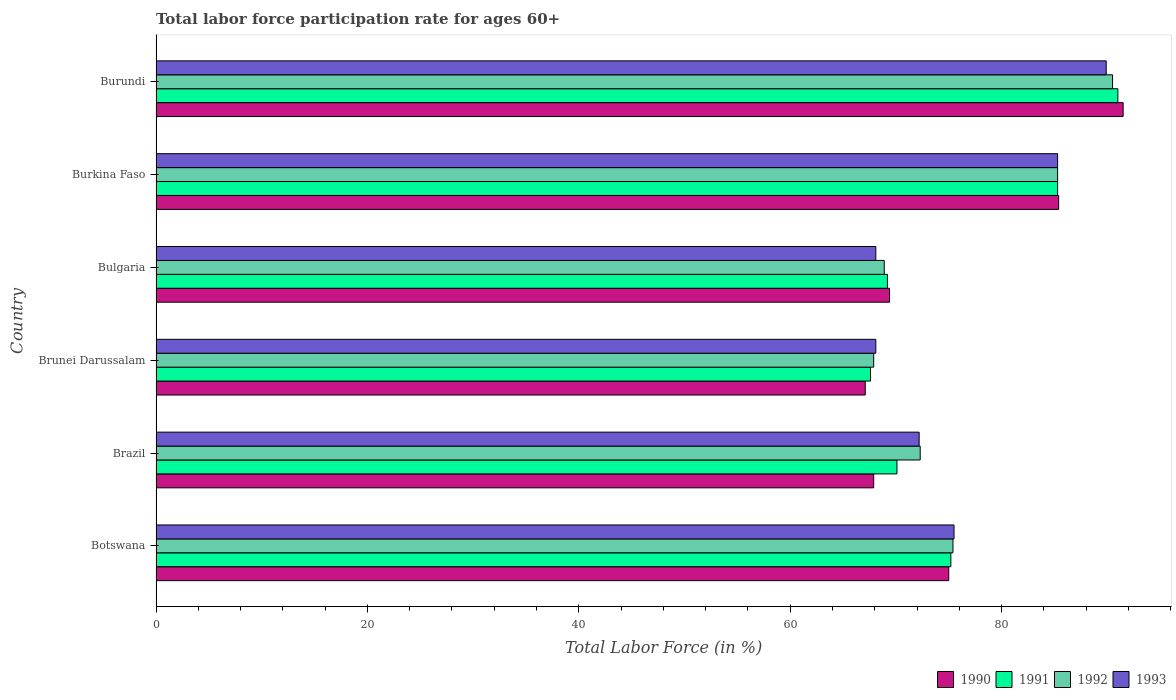How many groups of bars are there?
Your response must be concise. 6. How many bars are there on the 6th tick from the top?
Offer a terse response. 4. How many bars are there on the 4th tick from the bottom?
Give a very brief answer. 4. What is the label of the 3rd group of bars from the top?
Offer a very short reply. Bulgaria. In how many cases, is the number of bars for a given country not equal to the number of legend labels?
Your answer should be compact. 0. What is the labor force participation rate in 1992 in Burkina Faso?
Provide a short and direct response. 85.3. Across all countries, what is the maximum labor force participation rate in 1992?
Ensure brevity in your answer.  90.5. Across all countries, what is the minimum labor force participation rate in 1990?
Give a very brief answer. 67.1. In which country was the labor force participation rate in 1990 maximum?
Your answer should be very brief. Burundi. In which country was the labor force participation rate in 1991 minimum?
Keep it short and to the point. Brunei Darussalam. What is the total labor force participation rate in 1991 in the graph?
Your answer should be compact. 458.4. What is the difference between the labor force participation rate in 1992 in Botswana and that in Brunei Darussalam?
Give a very brief answer. 7.5. What is the difference between the labor force participation rate in 1992 in Burundi and the labor force participation rate in 1991 in Brunei Darussalam?
Provide a succinct answer. 22.9. What is the average labor force participation rate in 1993 per country?
Your answer should be very brief. 76.52. What is the difference between the labor force participation rate in 1993 and labor force participation rate in 1990 in Botswana?
Your answer should be compact. 0.5. In how many countries, is the labor force participation rate in 1992 greater than 4 %?
Provide a succinct answer. 6. What is the ratio of the labor force participation rate in 1992 in Botswana to that in Burkina Faso?
Make the answer very short. 0.88. Is the difference between the labor force participation rate in 1993 in Burkina Faso and Burundi greater than the difference between the labor force participation rate in 1990 in Burkina Faso and Burundi?
Keep it short and to the point. Yes. What is the difference between the highest and the second highest labor force participation rate in 1990?
Your answer should be very brief. 6.1. What is the difference between the highest and the lowest labor force participation rate in 1990?
Your response must be concise. 24.4. Is it the case that in every country, the sum of the labor force participation rate in 1992 and labor force participation rate in 1991 is greater than the sum of labor force participation rate in 1990 and labor force participation rate in 1993?
Give a very brief answer. No. What does the 1st bar from the bottom in Brunei Darussalam represents?
Offer a terse response. 1990. How many bars are there?
Provide a succinct answer. 24. Are all the bars in the graph horizontal?
Provide a short and direct response. Yes. Are the values on the major ticks of X-axis written in scientific E-notation?
Keep it short and to the point. No. Does the graph contain any zero values?
Make the answer very short. No. Does the graph contain grids?
Your answer should be very brief. No. How many legend labels are there?
Offer a very short reply. 4. What is the title of the graph?
Ensure brevity in your answer.  Total labor force participation rate for ages 60+. Does "1983" appear as one of the legend labels in the graph?
Make the answer very short. No. What is the label or title of the X-axis?
Make the answer very short. Total Labor Force (in %). What is the label or title of the Y-axis?
Offer a terse response. Country. What is the Total Labor Force (in %) of 1991 in Botswana?
Give a very brief answer. 75.2. What is the Total Labor Force (in %) in 1992 in Botswana?
Your response must be concise. 75.4. What is the Total Labor Force (in %) of 1993 in Botswana?
Give a very brief answer. 75.5. What is the Total Labor Force (in %) in 1990 in Brazil?
Your answer should be very brief. 67.9. What is the Total Labor Force (in %) in 1991 in Brazil?
Make the answer very short. 70.1. What is the Total Labor Force (in %) of 1992 in Brazil?
Offer a terse response. 72.3. What is the Total Labor Force (in %) of 1993 in Brazil?
Give a very brief answer. 72.2. What is the Total Labor Force (in %) of 1990 in Brunei Darussalam?
Your response must be concise. 67.1. What is the Total Labor Force (in %) of 1991 in Brunei Darussalam?
Keep it short and to the point. 67.6. What is the Total Labor Force (in %) of 1992 in Brunei Darussalam?
Give a very brief answer. 67.9. What is the Total Labor Force (in %) in 1993 in Brunei Darussalam?
Offer a very short reply. 68.1. What is the Total Labor Force (in %) of 1990 in Bulgaria?
Offer a very short reply. 69.4. What is the Total Labor Force (in %) in 1991 in Bulgaria?
Give a very brief answer. 69.2. What is the Total Labor Force (in %) in 1992 in Bulgaria?
Offer a terse response. 68.9. What is the Total Labor Force (in %) in 1993 in Bulgaria?
Provide a short and direct response. 68.1. What is the Total Labor Force (in %) of 1990 in Burkina Faso?
Provide a succinct answer. 85.4. What is the Total Labor Force (in %) of 1991 in Burkina Faso?
Give a very brief answer. 85.3. What is the Total Labor Force (in %) of 1992 in Burkina Faso?
Provide a succinct answer. 85.3. What is the Total Labor Force (in %) in 1993 in Burkina Faso?
Your response must be concise. 85.3. What is the Total Labor Force (in %) in 1990 in Burundi?
Make the answer very short. 91.5. What is the Total Labor Force (in %) of 1991 in Burundi?
Offer a terse response. 91. What is the Total Labor Force (in %) of 1992 in Burundi?
Give a very brief answer. 90.5. What is the Total Labor Force (in %) of 1993 in Burundi?
Give a very brief answer. 89.9. Across all countries, what is the maximum Total Labor Force (in %) in 1990?
Give a very brief answer. 91.5. Across all countries, what is the maximum Total Labor Force (in %) of 1991?
Offer a terse response. 91. Across all countries, what is the maximum Total Labor Force (in %) in 1992?
Provide a short and direct response. 90.5. Across all countries, what is the maximum Total Labor Force (in %) of 1993?
Offer a very short reply. 89.9. Across all countries, what is the minimum Total Labor Force (in %) of 1990?
Provide a succinct answer. 67.1. Across all countries, what is the minimum Total Labor Force (in %) of 1991?
Your response must be concise. 67.6. Across all countries, what is the minimum Total Labor Force (in %) in 1992?
Offer a terse response. 67.9. Across all countries, what is the minimum Total Labor Force (in %) in 1993?
Give a very brief answer. 68.1. What is the total Total Labor Force (in %) of 1990 in the graph?
Offer a terse response. 456.3. What is the total Total Labor Force (in %) in 1991 in the graph?
Give a very brief answer. 458.4. What is the total Total Labor Force (in %) in 1992 in the graph?
Ensure brevity in your answer.  460.3. What is the total Total Labor Force (in %) of 1993 in the graph?
Your answer should be compact. 459.1. What is the difference between the Total Labor Force (in %) of 1990 in Botswana and that in Brazil?
Your response must be concise. 7.1. What is the difference between the Total Labor Force (in %) in 1990 in Botswana and that in Brunei Darussalam?
Ensure brevity in your answer.  7.9. What is the difference between the Total Labor Force (in %) in 1993 in Botswana and that in Brunei Darussalam?
Offer a very short reply. 7.4. What is the difference between the Total Labor Force (in %) in 1990 in Botswana and that in Bulgaria?
Keep it short and to the point. 5.6. What is the difference between the Total Labor Force (in %) of 1991 in Botswana and that in Bulgaria?
Your answer should be very brief. 6. What is the difference between the Total Labor Force (in %) in 1993 in Botswana and that in Bulgaria?
Your response must be concise. 7.4. What is the difference between the Total Labor Force (in %) of 1993 in Botswana and that in Burkina Faso?
Your answer should be very brief. -9.8. What is the difference between the Total Labor Force (in %) of 1990 in Botswana and that in Burundi?
Keep it short and to the point. -16.5. What is the difference between the Total Labor Force (in %) of 1991 in Botswana and that in Burundi?
Provide a succinct answer. -15.8. What is the difference between the Total Labor Force (in %) in 1992 in Botswana and that in Burundi?
Keep it short and to the point. -15.1. What is the difference between the Total Labor Force (in %) of 1993 in Botswana and that in Burundi?
Make the answer very short. -14.4. What is the difference between the Total Labor Force (in %) of 1990 in Brazil and that in Brunei Darussalam?
Keep it short and to the point. 0.8. What is the difference between the Total Labor Force (in %) in 1990 in Brazil and that in Bulgaria?
Provide a succinct answer. -1.5. What is the difference between the Total Labor Force (in %) in 1991 in Brazil and that in Bulgaria?
Offer a terse response. 0.9. What is the difference between the Total Labor Force (in %) in 1992 in Brazil and that in Bulgaria?
Make the answer very short. 3.4. What is the difference between the Total Labor Force (in %) in 1993 in Brazil and that in Bulgaria?
Your response must be concise. 4.1. What is the difference between the Total Labor Force (in %) of 1990 in Brazil and that in Burkina Faso?
Offer a terse response. -17.5. What is the difference between the Total Labor Force (in %) in 1991 in Brazil and that in Burkina Faso?
Give a very brief answer. -15.2. What is the difference between the Total Labor Force (in %) in 1992 in Brazil and that in Burkina Faso?
Keep it short and to the point. -13. What is the difference between the Total Labor Force (in %) of 1993 in Brazil and that in Burkina Faso?
Offer a terse response. -13.1. What is the difference between the Total Labor Force (in %) in 1990 in Brazil and that in Burundi?
Offer a very short reply. -23.6. What is the difference between the Total Labor Force (in %) of 1991 in Brazil and that in Burundi?
Offer a terse response. -20.9. What is the difference between the Total Labor Force (in %) of 1992 in Brazil and that in Burundi?
Your answer should be compact. -18.2. What is the difference between the Total Labor Force (in %) of 1993 in Brazil and that in Burundi?
Your response must be concise. -17.7. What is the difference between the Total Labor Force (in %) in 1990 in Brunei Darussalam and that in Bulgaria?
Provide a short and direct response. -2.3. What is the difference between the Total Labor Force (in %) in 1990 in Brunei Darussalam and that in Burkina Faso?
Offer a very short reply. -18.3. What is the difference between the Total Labor Force (in %) in 1991 in Brunei Darussalam and that in Burkina Faso?
Keep it short and to the point. -17.7. What is the difference between the Total Labor Force (in %) in 1992 in Brunei Darussalam and that in Burkina Faso?
Your answer should be very brief. -17.4. What is the difference between the Total Labor Force (in %) of 1993 in Brunei Darussalam and that in Burkina Faso?
Your answer should be very brief. -17.2. What is the difference between the Total Labor Force (in %) in 1990 in Brunei Darussalam and that in Burundi?
Make the answer very short. -24.4. What is the difference between the Total Labor Force (in %) of 1991 in Brunei Darussalam and that in Burundi?
Offer a very short reply. -23.4. What is the difference between the Total Labor Force (in %) of 1992 in Brunei Darussalam and that in Burundi?
Provide a succinct answer. -22.6. What is the difference between the Total Labor Force (in %) of 1993 in Brunei Darussalam and that in Burundi?
Offer a terse response. -21.8. What is the difference between the Total Labor Force (in %) of 1991 in Bulgaria and that in Burkina Faso?
Your answer should be very brief. -16.1. What is the difference between the Total Labor Force (in %) in 1992 in Bulgaria and that in Burkina Faso?
Ensure brevity in your answer.  -16.4. What is the difference between the Total Labor Force (in %) of 1993 in Bulgaria and that in Burkina Faso?
Provide a short and direct response. -17.2. What is the difference between the Total Labor Force (in %) in 1990 in Bulgaria and that in Burundi?
Ensure brevity in your answer.  -22.1. What is the difference between the Total Labor Force (in %) of 1991 in Bulgaria and that in Burundi?
Make the answer very short. -21.8. What is the difference between the Total Labor Force (in %) of 1992 in Bulgaria and that in Burundi?
Your answer should be compact. -21.6. What is the difference between the Total Labor Force (in %) in 1993 in Bulgaria and that in Burundi?
Ensure brevity in your answer.  -21.8. What is the difference between the Total Labor Force (in %) of 1990 in Burkina Faso and that in Burundi?
Your response must be concise. -6.1. What is the difference between the Total Labor Force (in %) in 1991 in Burkina Faso and that in Burundi?
Your response must be concise. -5.7. What is the difference between the Total Labor Force (in %) of 1992 in Burkina Faso and that in Burundi?
Your answer should be compact. -5.2. What is the difference between the Total Labor Force (in %) of 1990 in Botswana and the Total Labor Force (in %) of 1991 in Brazil?
Ensure brevity in your answer.  4.9. What is the difference between the Total Labor Force (in %) in 1990 in Botswana and the Total Labor Force (in %) in 1992 in Brazil?
Provide a succinct answer. 2.7. What is the difference between the Total Labor Force (in %) in 1990 in Botswana and the Total Labor Force (in %) in 1993 in Brazil?
Keep it short and to the point. 2.8. What is the difference between the Total Labor Force (in %) of 1991 in Botswana and the Total Labor Force (in %) of 1993 in Brazil?
Keep it short and to the point. 3. What is the difference between the Total Labor Force (in %) in 1990 in Botswana and the Total Labor Force (in %) in 1991 in Brunei Darussalam?
Give a very brief answer. 7.4. What is the difference between the Total Labor Force (in %) of 1990 in Botswana and the Total Labor Force (in %) of 1992 in Brunei Darussalam?
Provide a succinct answer. 7.1. What is the difference between the Total Labor Force (in %) in 1990 in Botswana and the Total Labor Force (in %) in 1993 in Brunei Darussalam?
Your response must be concise. 6.9. What is the difference between the Total Labor Force (in %) in 1990 in Botswana and the Total Labor Force (in %) in 1991 in Bulgaria?
Your answer should be very brief. 5.8. What is the difference between the Total Labor Force (in %) in 1990 in Botswana and the Total Labor Force (in %) in 1992 in Bulgaria?
Give a very brief answer. 6.1. What is the difference between the Total Labor Force (in %) of 1990 in Botswana and the Total Labor Force (in %) of 1993 in Bulgaria?
Keep it short and to the point. 6.9. What is the difference between the Total Labor Force (in %) in 1991 in Botswana and the Total Labor Force (in %) in 1992 in Bulgaria?
Provide a short and direct response. 6.3. What is the difference between the Total Labor Force (in %) of 1992 in Botswana and the Total Labor Force (in %) of 1993 in Bulgaria?
Your answer should be compact. 7.3. What is the difference between the Total Labor Force (in %) of 1990 in Botswana and the Total Labor Force (in %) of 1991 in Burkina Faso?
Offer a terse response. -10.3. What is the difference between the Total Labor Force (in %) of 1990 in Botswana and the Total Labor Force (in %) of 1992 in Burkina Faso?
Your answer should be compact. -10.3. What is the difference between the Total Labor Force (in %) in 1990 in Botswana and the Total Labor Force (in %) in 1991 in Burundi?
Provide a succinct answer. -16. What is the difference between the Total Labor Force (in %) in 1990 in Botswana and the Total Labor Force (in %) in 1992 in Burundi?
Provide a succinct answer. -15.5. What is the difference between the Total Labor Force (in %) of 1990 in Botswana and the Total Labor Force (in %) of 1993 in Burundi?
Offer a very short reply. -14.9. What is the difference between the Total Labor Force (in %) of 1991 in Botswana and the Total Labor Force (in %) of 1992 in Burundi?
Your answer should be very brief. -15.3. What is the difference between the Total Labor Force (in %) in 1991 in Botswana and the Total Labor Force (in %) in 1993 in Burundi?
Provide a succinct answer. -14.7. What is the difference between the Total Labor Force (in %) of 1992 in Botswana and the Total Labor Force (in %) of 1993 in Burundi?
Make the answer very short. -14.5. What is the difference between the Total Labor Force (in %) of 1990 in Brazil and the Total Labor Force (in %) of 1992 in Brunei Darussalam?
Your answer should be compact. 0. What is the difference between the Total Labor Force (in %) of 1990 in Brazil and the Total Labor Force (in %) of 1993 in Brunei Darussalam?
Give a very brief answer. -0.2. What is the difference between the Total Labor Force (in %) of 1992 in Brazil and the Total Labor Force (in %) of 1993 in Brunei Darussalam?
Your response must be concise. 4.2. What is the difference between the Total Labor Force (in %) of 1992 in Brazil and the Total Labor Force (in %) of 1993 in Bulgaria?
Give a very brief answer. 4.2. What is the difference between the Total Labor Force (in %) of 1990 in Brazil and the Total Labor Force (in %) of 1991 in Burkina Faso?
Give a very brief answer. -17.4. What is the difference between the Total Labor Force (in %) of 1990 in Brazil and the Total Labor Force (in %) of 1992 in Burkina Faso?
Your response must be concise. -17.4. What is the difference between the Total Labor Force (in %) of 1990 in Brazil and the Total Labor Force (in %) of 1993 in Burkina Faso?
Offer a very short reply. -17.4. What is the difference between the Total Labor Force (in %) of 1991 in Brazil and the Total Labor Force (in %) of 1992 in Burkina Faso?
Keep it short and to the point. -15.2. What is the difference between the Total Labor Force (in %) in 1991 in Brazil and the Total Labor Force (in %) in 1993 in Burkina Faso?
Give a very brief answer. -15.2. What is the difference between the Total Labor Force (in %) in 1990 in Brazil and the Total Labor Force (in %) in 1991 in Burundi?
Ensure brevity in your answer.  -23.1. What is the difference between the Total Labor Force (in %) in 1990 in Brazil and the Total Labor Force (in %) in 1992 in Burundi?
Your response must be concise. -22.6. What is the difference between the Total Labor Force (in %) in 1990 in Brazil and the Total Labor Force (in %) in 1993 in Burundi?
Your answer should be compact. -22. What is the difference between the Total Labor Force (in %) in 1991 in Brazil and the Total Labor Force (in %) in 1992 in Burundi?
Your answer should be compact. -20.4. What is the difference between the Total Labor Force (in %) of 1991 in Brazil and the Total Labor Force (in %) of 1993 in Burundi?
Keep it short and to the point. -19.8. What is the difference between the Total Labor Force (in %) of 1992 in Brazil and the Total Labor Force (in %) of 1993 in Burundi?
Give a very brief answer. -17.6. What is the difference between the Total Labor Force (in %) of 1990 in Brunei Darussalam and the Total Labor Force (in %) of 1991 in Bulgaria?
Your answer should be very brief. -2.1. What is the difference between the Total Labor Force (in %) in 1990 in Brunei Darussalam and the Total Labor Force (in %) in 1993 in Bulgaria?
Provide a short and direct response. -1. What is the difference between the Total Labor Force (in %) in 1991 in Brunei Darussalam and the Total Labor Force (in %) in 1993 in Bulgaria?
Your answer should be very brief. -0.5. What is the difference between the Total Labor Force (in %) in 1990 in Brunei Darussalam and the Total Labor Force (in %) in 1991 in Burkina Faso?
Make the answer very short. -18.2. What is the difference between the Total Labor Force (in %) in 1990 in Brunei Darussalam and the Total Labor Force (in %) in 1992 in Burkina Faso?
Keep it short and to the point. -18.2. What is the difference between the Total Labor Force (in %) in 1990 in Brunei Darussalam and the Total Labor Force (in %) in 1993 in Burkina Faso?
Offer a very short reply. -18.2. What is the difference between the Total Labor Force (in %) in 1991 in Brunei Darussalam and the Total Labor Force (in %) in 1992 in Burkina Faso?
Give a very brief answer. -17.7. What is the difference between the Total Labor Force (in %) of 1991 in Brunei Darussalam and the Total Labor Force (in %) of 1993 in Burkina Faso?
Give a very brief answer. -17.7. What is the difference between the Total Labor Force (in %) in 1992 in Brunei Darussalam and the Total Labor Force (in %) in 1993 in Burkina Faso?
Offer a very short reply. -17.4. What is the difference between the Total Labor Force (in %) in 1990 in Brunei Darussalam and the Total Labor Force (in %) in 1991 in Burundi?
Your answer should be very brief. -23.9. What is the difference between the Total Labor Force (in %) in 1990 in Brunei Darussalam and the Total Labor Force (in %) in 1992 in Burundi?
Give a very brief answer. -23.4. What is the difference between the Total Labor Force (in %) in 1990 in Brunei Darussalam and the Total Labor Force (in %) in 1993 in Burundi?
Your answer should be very brief. -22.8. What is the difference between the Total Labor Force (in %) in 1991 in Brunei Darussalam and the Total Labor Force (in %) in 1992 in Burundi?
Your answer should be very brief. -22.9. What is the difference between the Total Labor Force (in %) of 1991 in Brunei Darussalam and the Total Labor Force (in %) of 1993 in Burundi?
Your answer should be compact. -22.3. What is the difference between the Total Labor Force (in %) in 1990 in Bulgaria and the Total Labor Force (in %) in 1991 in Burkina Faso?
Keep it short and to the point. -15.9. What is the difference between the Total Labor Force (in %) of 1990 in Bulgaria and the Total Labor Force (in %) of 1992 in Burkina Faso?
Provide a succinct answer. -15.9. What is the difference between the Total Labor Force (in %) in 1990 in Bulgaria and the Total Labor Force (in %) in 1993 in Burkina Faso?
Your answer should be very brief. -15.9. What is the difference between the Total Labor Force (in %) in 1991 in Bulgaria and the Total Labor Force (in %) in 1992 in Burkina Faso?
Provide a succinct answer. -16.1. What is the difference between the Total Labor Force (in %) of 1991 in Bulgaria and the Total Labor Force (in %) of 1993 in Burkina Faso?
Make the answer very short. -16.1. What is the difference between the Total Labor Force (in %) in 1992 in Bulgaria and the Total Labor Force (in %) in 1993 in Burkina Faso?
Keep it short and to the point. -16.4. What is the difference between the Total Labor Force (in %) of 1990 in Bulgaria and the Total Labor Force (in %) of 1991 in Burundi?
Make the answer very short. -21.6. What is the difference between the Total Labor Force (in %) in 1990 in Bulgaria and the Total Labor Force (in %) in 1992 in Burundi?
Keep it short and to the point. -21.1. What is the difference between the Total Labor Force (in %) in 1990 in Bulgaria and the Total Labor Force (in %) in 1993 in Burundi?
Provide a short and direct response. -20.5. What is the difference between the Total Labor Force (in %) in 1991 in Bulgaria and the Total Labor Force (in %) in 1992 in Burundi?
Ensure brevity in your answer.  -21.3. What is the difference between the Total Labor Force (in %) in 1991 in Bulgaria and the Total Labor Force (in %) in 1993 in Burundi?
Your response must be concise. -20.7. What is the difference between the Total Labor Force (in %) in 1992 in Bulgaria and the Total Labor Force (in %) in 1993 in Burundi?
Your answer should be compact. -21. What is the difference between the Total Labor Force (in %) of 1990 in Burkina Faso and the Total Labor Force (in %) of 1991 in Burundi?
Provide a short and direct response. -5.6. What is the difference between the Total Labor Force (in %) of 1990 in Burkina Faso and the Total Labor Force (in %) of 1992 in Burundi?
Make the answer very short. -5.1. What is the average Total Labor Force (in %) of 1990 per country?
Offer a terse response. 76.05. What is the average Total Labor Force (in %) in 1991 per country?
Offer a very short reply. 76.4. What is the average Total Labor Force (in %) of 1992 per country?
Provide a short and direct response. 76.72. What is the average Total Labor Force (in %) of 1993 per country?
Give a very brief answer. 76.52. What is the difference between the Total Labor Force (in %) in 1990 and Total Labor Force (in %) in 1991 in Botswana?
Give a very brief answer. -0.2. What is the difference between the Total Labor Force (in %) in 1990 and Total Labor Force (in %) in 1992 in Botswana?
Provide a short and direct response. -0.4. What is the difference between the Total Labor Force (in %) of 1990 and Total Labor Force (in %) of 1993 in Botswana?
Offer a terse response. -0.5. What is the difference between the Total Labor Force (in %) in 1991 and Total Labor Force (in %) in 1993 in Botswana?
Make the answer very short. -0.3. What is the difference between the Total Labor Force (in %) in 1990 and Total Labor Force (in %) in 1992 in Brazil?
Ensure brevity in your answer.  -4.4. What is the difference between the Total Labor Force (in %) of 1990 and Total Labor Force (in %) of 1993 in Brazil?
Your answer should be very brief. -4.3. What is the difference between the Total Labor Force (in %) of 1991 and Total Labor Force (in %) of 1992 in Brazil?
Offer a very short reply. -2.2. What is the difference between the Total Labor Force (in %) in 1992 and Total Labor Force (in %) in 1993 in Brazil?
Provide a succinct answer. 0.1. What is the difference between the Total Labor Force (in %) in 1990 and Total Labor Force (in %) in 1991 in Brunei Darussalam?
Make the answer very short. -0.5. What is the difference between the Total Labor Force (in %) of 1990 and Total Labor Force (in %) of 1992 in Brunei Darussalam?
Offer a very short reply. -0.8. What is the difference between the Total Labor Force (in %) of 1991 and Total Labor Force (in %) of 1992 in Brunei Darussalam?
Provide a succinct answer. -0.3. What is the difference between the Total Labor Force (in %) in 1992 and Total Labor Force (in %) in 1993 in Brunei Darussalam?
Ensure brevity in your answer.  -0.2. What is the difference between the Total Labor Force (in %) in 1990 and Total Labor Force (in %) in 1991 in Bulgaria?
Keep it short and to the point. 0.2. What is the difference between the Total Labor Force (in %) in 1990 and Total Labor Force (in %) in 1992 in Bulgaria?
Make the answer very short. 0.5. What is the difference between the Total Labor Force (in %) of 1990 and Total Labor Force (in %) of 1993 in Bulgaria?
Keep it short and to the point. 1.3. What is the difference between the Total Labor Force (in %) in 1991 and Total Labor Force (in %) in 1992 in Bulgaria?
Keep it short and to the point. 0.3. What is the difference between the Total Labor Force (in %) of 1991 and Total Labor Force (in %) of 1993 in Bulgaria?
Provide a short and direct response. 1.1. What is the difference between the Total Labor Force (in %) in 1990 and Total Labor Force (in %) in 1992 in Burkina Faso?
Give a very brief answer. 0.1. What is the difference between the Total Labor Force (in %) of 1991 and Total Labor Force (in %) of 1993 in Burkina Faso?
Provide a short and direct response. 0. What is the difference between the Total Labor Force (in %) of 1992 and Total Labor Force (in %) of 1993 in Burkina Faso?
Give a very brief answer. 0. What is the difference between the Total Labor Force (in %) of 1990 and Total Labor Force (in %) of 1992 in Burundi?
Offer a very short reply. 1. What is the difference between the Total Labor Force (in %) of 1991 and Total Labor Force (in %) of 1992 in Burundi?
Make the answer very short. 0.5. What is the difference between the Total Labor Force (in %) in 1992 and Total Labor Force (in %) in 1993 in Burundi?
Keep it short and to the point. 0.6. What is the ratio of the Total Labor Force (in %) in 1990 in Botswana to that in Brazil?
Ensure brevity in your answer.  1.1. What is the ratio of the Total Labor Force (in %) of 1991 in Botswana to that in Brazil?
Your response must be concise. 1.07. What is the ratio of the Total Labor Force (in %) in 1992 in Botswana to that in Brazil?
Offer a terse response. 1.04. What is the ratio of the Total Labor Force (in %) in 1993 in Botswana to that in Brazil?
Your answer should be very brief. 1.05. What is the ratio of the Total Labor Force (in %) of 1990 in Botswana to that in Brunei Darussalam?
Offer a very short reply. 1.12. What is the ratio of the Total Labor Force (in %) in 1991 in Botswana to that in Brunei Darussalam?
Ensure brevity in your answer.  1.11. What is the ratio of the Total Labor Force (in %) in 1992 in Botswana to that in Brunei Darussalam?
Ensure brevity in your answer.  1.11. What is the ratio of the Total Labor Force (in %) in 1993 in Botswana to that in Brunei Darussalam?
Your response must be concise. 1.11. What is the ratio of the Total Labor Force (in %) of 1990 in Botswana to that in Bulgaria?
Your answer should be compact. 1.08. What is the ratio of the Total Labor Force (in %) of 1991 in Botswana to that in Bulgaria?
Ensure brevity in your answer.  1.09. What is the ratio of the Total Labor Force (in %) in 1992 in Botswana to that in Bulgaria?
Offer a very short reply. 1.09. What is the ratio of the Total Labor Force (in %) of 1993 in Botswana to that in Bulgaria?
Give a very brief answer. 1.11. What is the ratio of the Total Labor Force (in %) in 1990 in Botswana to that in Burkina Faso?
Offer a very short reply. 0.88. What is the ratio of the Total Labor Force (in %) in 1991 in Botswana to that in Burkina Faso?
Keep it short and to the point. 0.88. What is the ratio of the Total Labor Force (in %) in 1992 in Botswana to that in Burkina Faso?
Keep it short and to the point. 0.88. What is the ratio of the Total Labor Force (in %) of 1993 in Botswana to that in Burkina Faso?
Provide a short and direct response. 0.89. What is the ratio of the Total Labor Force (in %) in 1990 in Botswana to that in Burundi?
Provide a short and direct response. 0.82. What is the ratio of the Total Labor Force (in %) in 1991 in Botswana to that in Burundi?
Ensure brevity in your answer.  0.83. What is the ratio of the Total Labor Force (in %) in 1992 in Botswana to that in Burundi?
Your answer should be very brief. 0.83. What is the ratio of the Total Labor Force (in %) in 1993 in Botswana to that in Burundi?
Provide a short and direct response. 0.84. What is the ratio of the Total Labor Force (in %) of 1990 in Brazil to that in Brunei Darussalam?
Make the answer very short. 1.01. What is the ratio of the Total Labor Force (in %) of 1991 in Brazil to that in Brunei Darussalam?
Provide a succinct answer. 1.04. What is the ratio of the Total Labor Force (in %) of 1992 in Brazil to that in Brunei Darussalam?
Your response must be concise. 1.06. What is the ratio of the Total Labor Force (in %) of 1993 in Brazil to that in Brunei Darussalam?
Your response must be concise. 1.06. What is the ratio of the Total Labor Force (in %) in 1990 in Brazil to that in Bulgaria?
Provide a short and direct response. 0.98. What is the ratio of the Total Labor Force (in %) of 1992 in Brazil to that in Bulgaria?
Your answer should be very brief. 1.05. What is the ratio of the Total Labor Force (in %) in 1993 in Brazil to that in Bulgaria?
Ensure brevity in your answer.  1.06. What is the ratio of the Total Labor Force (in %) of 1990 in Brazil to that in Burkina Faso?
Make the answer very short. 0.8. What is the ratio of the Total Labor Force (in %) of 1991 in Brazil to that in Burkina Faso?
Your response must be concise. 0.82. What is the ratio of the Total Labor Force (in %) of 1992 in Brazil to that in Burkina Faso?
Make the answer very short. 0.85. What is the ratio of the Total Labor Force (in %) in 1993 in Brazil to that in Burkina Faso?
Your answer should be compact. 0.85. What is the ratio of the Total Labor Force (in %) of 1990 in Brazil to that in Burundi?
Your response must be concise. 0.74. What is the ratio of the Total Labor Force (in %) of 1991 in Brazil to that in Burundi?
Offer a terse response. 0.77. What is the ratio of the Total Labor Force (in %) of 1992 in Brazil to that in Burundi?
Your answer should be compact. 0.8. What is the ratio of the Total Labor Force (in %) of 1993 in Brazil to that in Burundi?
Offer a very short reply. 0.8. What is the ratio of the Total Labor Force (in %) in 1990 in Brunei Darussalam to that in Bulgaria?
Offer a terse response. 0.97. What is the ratio of the Total Labor Force (in %) in 1991 in Brunei Darussalam to that in Bulgaria?
Offer a terse response. 0.98. What is the ratio of the Total Labor Force (in %) in 1992 in Brunei Darussalam to that in Bulgaria?
Your answer should be very brief. 0.99. What is the ratio of the Total Labor Force (in %) of 1993 in Brunei Darussalam to that in Bulgaria?
Offer a terse response. 1. What is the ratio of the Total Labor Force (in %) in 1990 in Brunei Darussalam to that in Burkina Faso?
Provide a short and direct response. 0.79. What is the ratio of the Total Labor Force (in %) in 1991 in Brunei Darussalam to that in Burkina Faso?
Your answer should be very brief. 0.79. What is the ratio of the Total Labor Force (in %) of 1992 in Brunei Darussalam to that in Burkina Faso?
Your answer should be very brief. 0.8. What is the ratio of the Total Labor Force (in %) in 1993 in Brunei Darussalam to that in Burkina Faso?
Your answer should be compact. 0.8. What is the ratio of the Total Labor Force (in %) of 1990 in Brunei Darussalam to that in Burundi?
Give a very brief answer. 0.73. What is the ratio of the Total Labor Force (in %) in 1991 in Brunei Darussalam to that in Burundi?
Provide a succinct answer. 0.74. What is the ratio of the Total Labor Force (in %) of 1992 in Brunei Darussalam to that in Burundi?
Make the answer very short. 0.75. What is the ratio of the Total Labor Force (in %) in 1993 in Brunei Darussalam to that in Burundi?
Ensure brevity in your answer.  0.76. What is the ratio of the Total Labor Force (in %) of 1990 in Bulgaria to that in Burkina Faso?
Offer a very short reply. 0.81. What is the ratio of the Total Labor Force (in %) of 1991 in Bulgaria to that in Burkina Faso?
Keep it short and to the point. 0.81. What is the ratio of the Total Labor Force (in %) in 1992 in Bulgaria to that in Burkina Faso?
Provide a short and direct response. 0.81. What is the ratio of the Total Labor Force (in %) in 1993 in Bulgaria to that in Burkina Faso?
Offer a terse response. 0.8. What is the ratio of the Total Labor Force (in %) of 1990 in Bulgaria to that in Burundi?
Offer a terse response. 0.76. What is the ratio of the Total Labor Force (in %) in 1991 in Bulgaria to that in Burundi?
Your answer should be compact. 0.76. What is the ratio of the Total Labor Force (in %) of 1992 in Bulgaria to that in Burundi?
Your answer should be very brief. 0.76. What is the ratio of the Total Labor Force (in %) of 1993 in Bulgaria to that in Burundi?
Keep it short and to the point. 0.76. What is the ratio of the Total Labor Force (in %) in 1991 in Burkina Faso to that in Burundi?
Keep it short and to the point. 0.94. What is the ratio of the Total Labor Force (in %) of 1992 in Burkina Faso to that in Burundi?
Give a very brief answer. 0.94. What is the ratio of the Total Labor Force (in %) of 1993 in Burkina Faso to that in Burundi?
Offer a terse response. 0.95. What is the difference between the highest and the second highest Total Labor Force (in %) in 1990?
Offer a very short reply. 6.1. What is the difference between the highest and the second highest Total Labor Force (in %) of 1991?
Your response must be concise. 5.7. What is the difference between the highest and the second highest Total Labor Force (in %) in 1993?
Your answer should be compact. 4.6. What is the difference between the highest and the lowest Total Labor Force (in %) of 1990?
Make the answer very short. 24.4. What is the difference between the highest and the lowest Total Labor Force (in %) of 1991?
Provide a short and direct response. 23.4. What is the difference between the highest and the lowest Total Labor Force (in %) of 1992?
Provide a short and direct response. 22.6. What is the difference between the highest and the lowest Total Labor Force (in %) in 1993?
Provide a succinct answer. 21.8. 